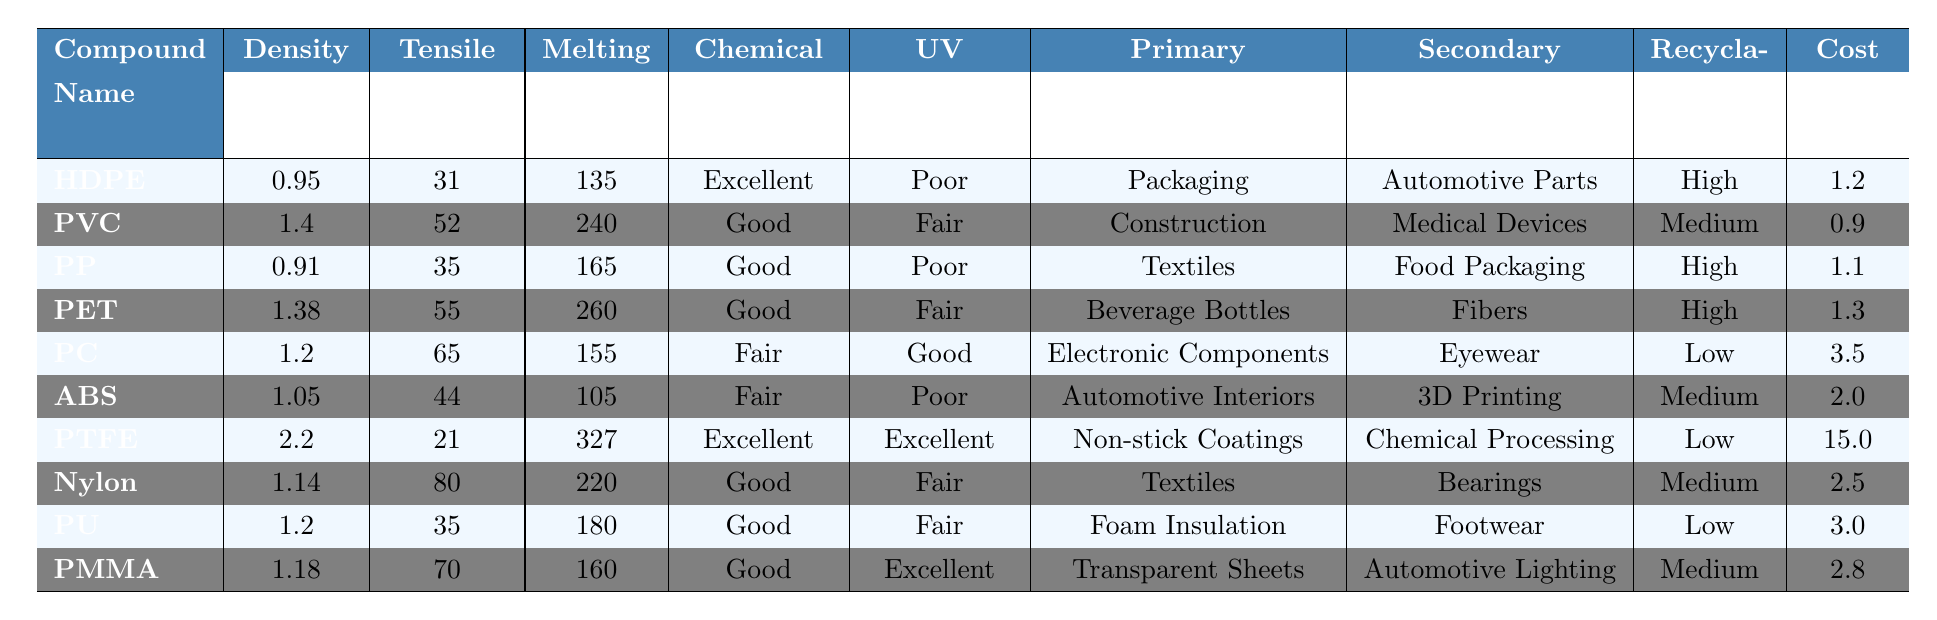What is the tensile strength of Polycarbonate (PC)? From the table, we can locate the row for Polycarbonate (PC) and find the tensile strength value listed as 65 MPa.
Answer: 65 MPa Which compound has the highest density? By scanning through the density values in the table, Polycarbonate (PC) has the highest density value at 2.2 g/cm³.
Answer: 2.2 g/cm³ What are the primary industrial applications of High-Density Polyethylene (HDPE)? The table shows that the primary industrial application for HDPE is Packaging.
Answer: Packaging How do the recyclability ratings of Polyvinyl Chloride (PVC) and Polylactic Acid (PLA) compare? PVC has a recyclability rating of Medium, while PLA is not listed in the table, making it impossible to compare directly.
Answer: Not applicable; PLA is not listed Is the chemical resistance of Polymethyl Methacrylate (PMMA) considered good? The table states that PMMA has Good chemical resistance, therefore the answer is yes.
Answer: Yes Which compound has the lowest cost per kilogram? The table lists the costs per kg for all compounds, and PVC has the lowest at $0.9 per kg.
Answer: $0.9 What is the average melting point of the six compounds with the lowest tensile strength? The six compounds with the lowest tensile strengths are PTFE (327 °C), HDPE (135 °C), ABS (105 °C), PP (165 °C), PU (180 °C), and PVC (240 °C). Their melting points sum to 327 + 135 + 105 + 165 + 180 + 240 = 1152 °C. The average is 1152/6 = 192 °C.
Answer: 192 °C Are any compounds listed as having poor UV resistance? There are three compounds in the table with Poor UV resistance: HDPE, PP, and ABS. Thus the answer is yes.
Answer: Yes What is the chemical resistance classification of Polyurethane (PU) compared to Polycarbonate (PC)? According to the table, PU has Good chemical resistance, while PC has Fair chemical resistance. This indicates PU is better than PC in terms of chemical resistance.
Answer: PU is better How does the tensile strength of Nylon compare to that of Polyacrylate Butadiene Styrene (ABS)? The table shows the tensile strength of Nylon is 80 MPa, while ABS has a tensile strength of 44 MPa, indicating Nylon is stronger than ABS.
Answer: Nylon is stronger What is the total count of compounds listed that are suitable for recycling? From the table, the compounds with High recyclability are HDPE, PP, PET, and the ones with Medium recyclability are PVC, ABS, Nylon, and PMMA, resulting in a total of 7 compounds suitable for recycling.
Answer: 7 compounds 